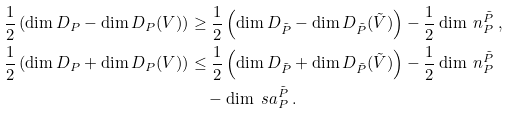<formula> <loc_0><loc_0><loc_500><loc_500>\frac { 1 } { 2 } \left ( \dim D _ { P } - \dim D _ { P } ( V ) \right ) & \geq \frac { 1 } { 2 } \left ( \dim D _ { \tilde { P } } - \dim D _ { \tilde { P } } ( \tilde { V } ) \right ) - \frac { 1 } { 2 } \dim \ n _ { P } ^ { \tilde { P } } \ , \\ \frac { 1 } { 2 } \left ( \dim D _ { P } + \dim D _ { P } ( V ) \right ) & \leq \frac { 1 } { 2 } \left ( \dim D _ { \tilde { P } } + \dim D _ { \tilde { P } } ( { \tilde { V } } ) \right ) - \frac { 1 } { 2 } \dim \ n _ { P } ^ { \tilde { P } } \\ & \quad - \dim \ s a _ { P } ^ { \tilde { P } } \ .</formula> 